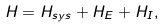<formula> <loc_0><loc_0><loc_500><loc_500>H = H _ { s y s } + H _ { E } + H _ { I } ,</formula> 